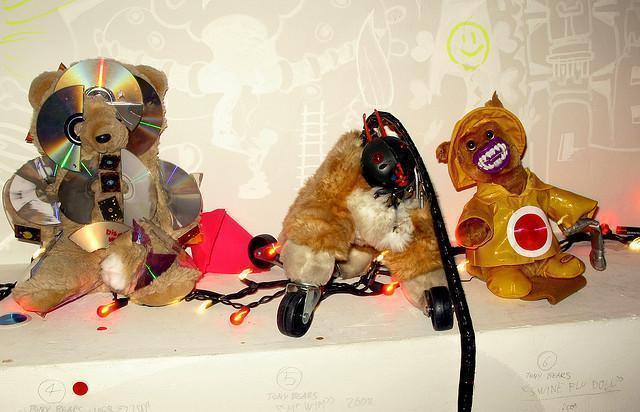What are the shattered items on the bear?
Answer the question by selecting the correct answer among the 4 following choices.
Options: Cassettes, 8-tracks, cds, records. Cds. 